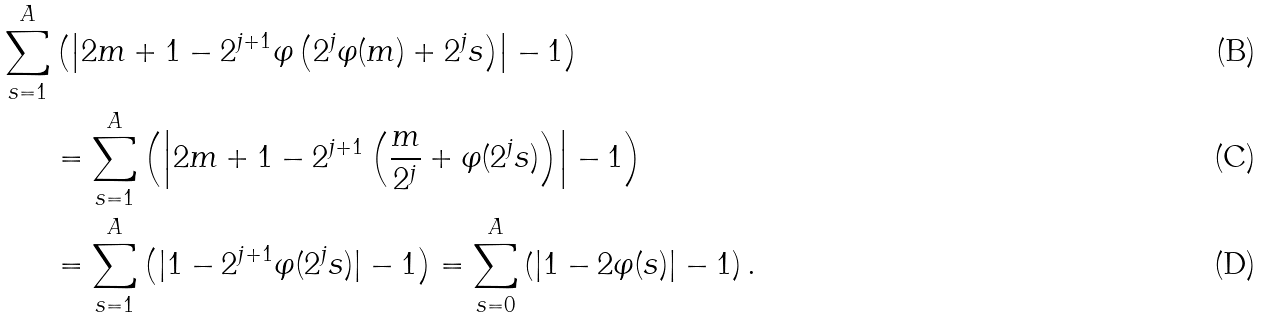<formula> <loc_0><loc_0><loc_500><loc_500>\sum _ { s = 1 } ^ { A } & \left ( \left | 2 m + 1 - 2 ^ { j + 1 } \varphi \left ( 2 ^ { j } \varphi ( m ) + 2 ^ { j } s \right ) \right | - 1 \right ) \\ & = \sum _ { s = 1 } ^ { A } \left ( \left | 2 m + 1 - 2 ^ { j + 1 } \left ( \frac { m } { 2 ^ { j } } + \varphi ( 2 ^ { j } s ) \right ) \right | - 1 \right ) \\ & = \sum _ { s = 1 } ^ { A } \left ( | 1 - 2 ^ { j + 1 } \varphi ( 2 ^ { j } s ) | - 1 \right ) = \sum _ { s = 0 } ^ { A } \left ( | 1 - 2 \varphi ( s ) | - 1 \right ) .</formula> 